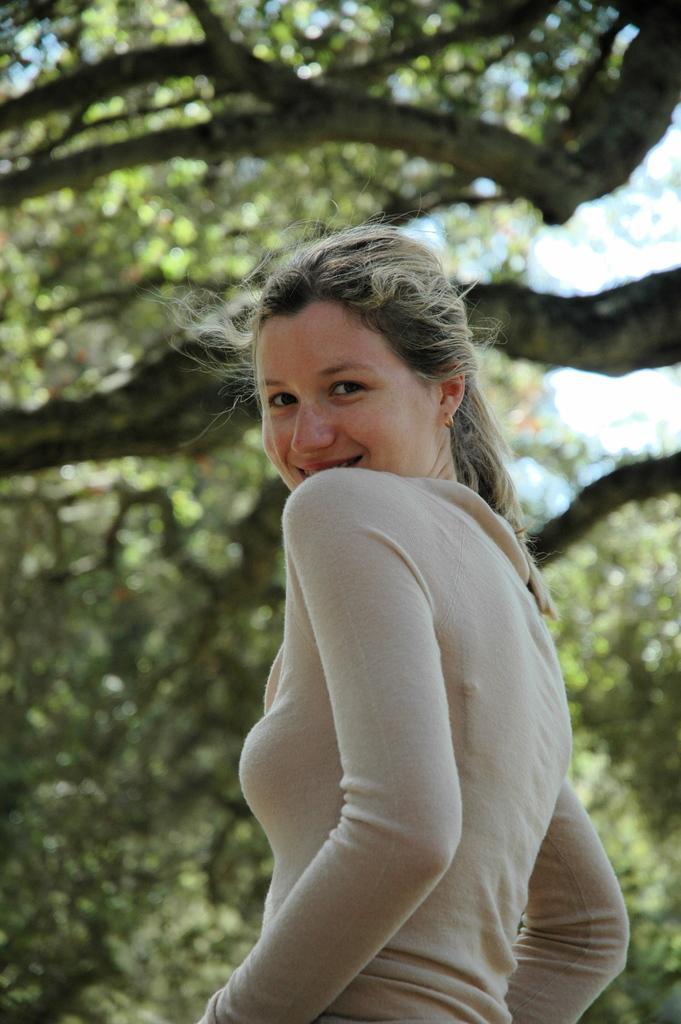Could you give a brief overview of what you see in this image? In this image there is a woman standing. Background there are trees. Behind there is sky. 